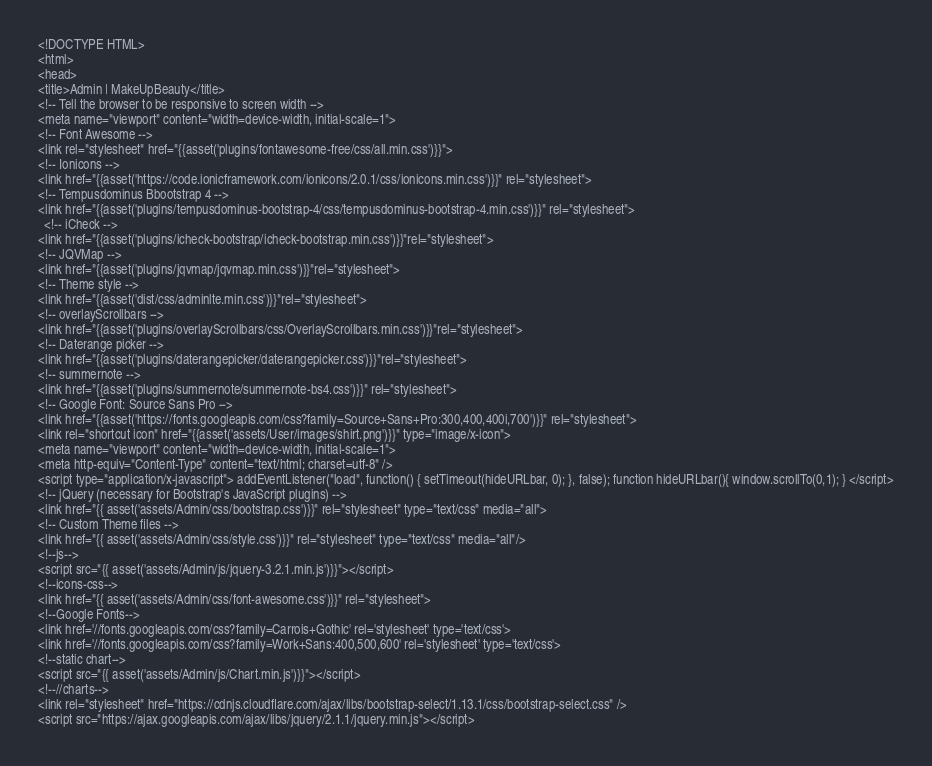Convert code to text. <code><loc_0><loc_0><loc_500><loc_500><_PHP_><!DOCTYPE HTML>
<html>
<head>
<title>Admin | MakeUpBeauty</title>
<!-- Tell the browser to be responsive to screen width -->
<meta name="viewport" content="width=device-width, initial-scale=1">
<!-- Font Awesome -->
<link rel="stylesheet" href="{{asset('plugins/fontawesome-free/css/all.min.css')}}">
<!-- Ionicons -->
<link href="{{asset('https://code.ionicframework.com/ionicons/2.0.1/css/ionicons.min.css')}}" rel="stylesheet">
<!-- Tempusdominus Bbootstrap 4 -->
<link href="{{asset('plugins/tempusdominus-bootstrap-4/css/tempusdominus-bootstrap-4.min.css')}}" rel="stylesheet">
  <!-- iCheck -->
<link href="{{asset('plugins/icheck-bootstrap/icheck-bootstrap.min.css')}}"rel="stylesheet">
<!-- JQVMap -->
<link href="{{asset('plugins/jqvmap/jqvmap.min.css')}}"rel="stylesheet">
<!-- Theme style -->
<link href="{{asset('dist/css/adminlte.min.css')}}"rel="stylesheet">
<!-- overlayScrollbars -->
<link href="{{asset('plugins/overlayScrollbars/css/OverlayScrollbars.min.css')}}"rel="stylesheet">
<!-- Daterange picker -->
<link href="{{asset('plugins/daterangepicker/daterangepicker.css')}}"rel="stylesheet">
<!-- summernote -->
<link href="{{asset('plugins/summernote/summernote-bs4.css')}}" rel="stylesheet">
<!-- Google Font: Source Sans Pro -->
<link href="{{asset('https://fonts.googleapis.com/css?family=Source+Sans+Pro:300,400,400i,700')}}" rel="stylesheet">
<link rel="shortcut icon" href="{{asset('assets/User/images/shirt.png')}}" type="image/x-icon">
<meta name="viewport" content="width=device-width, initial-scale=1">
<meta http-equiv="Content-Type" content="text/html; charset=utf-8" />
<script type="application/x-javascript"> addEventListener("load", function() { setTimeout(hideURLbar, 0); }, false); function hideURLbar(){ window.scrollTo(0,1); } </script>
<!-- jQuery (necessary for Bootstrap's JavaScript plugins) -->
<link href="{{ asset('assets/Admin/css/bootstrap.css')}}" rel="stylesheet" type="text/css" media="all">
<!-- Custom Theme files -->
<link href="{{ asset('assets/Admin/css/style.css')}}" rel="stylesheet" type="text/css" media="all"/>
<!--js-->
<script src="{{ asset('assets/Admin/js/jquery-3.2.1.min.js')}}"></script> 
<!--icons-css-->
<link href="{{ asset('assets/Admin/css/font-awesome.css')}}" rel="stylesheet"> 
<!--Google Fonts-->
<link href='//fonts.googleapis.com/css?family=Carrois+Gothic' rel='stylesheet' type='text/css'>
<link href='//fonts.googleapis.com/css?family=Work+Sans:400,500,600' rel='stylesheet' type='text/css'>
<!--static chart-->
<script src="{{ asset('assets/Admin/js/Chart.min.js')}}"></script>
<!--//charts-->
<link rel="stylesheet" href="https://cdnjs.cloudflare.com/ajax/libs/bootstrap-select/1.13.1/css/bootstrap-select.css" />
<script src="https://ajax.googleapis.com/ajax/libs/jquery/2.1.1/jquery.min.js"></script></code> 